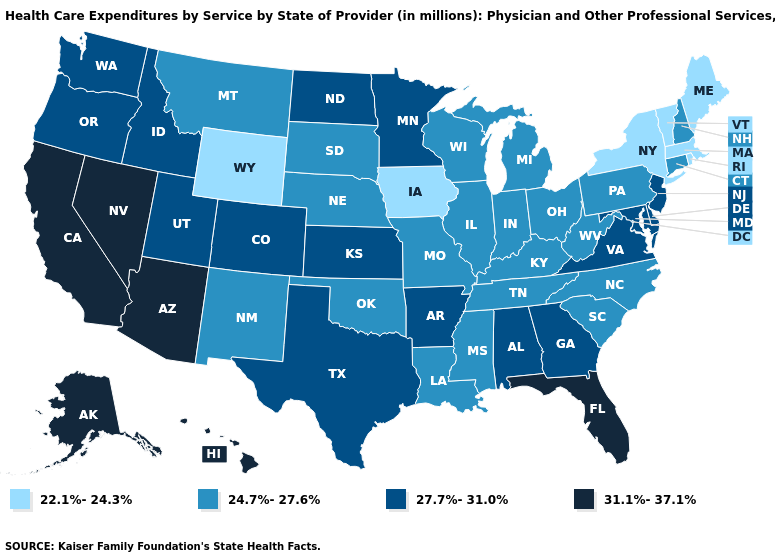Does Alaska have the highest value in the West?
Keep it brief. Yes. Which states have the highest value in the USA?
Concise answer only. Alaska, Arizona, California, Florida, Hawaii, Nevada. Does Arkansas have the highest value in the South?
Short answer required. No. Which states have the highest value in the USA?
Keep it brief. Alaska, Arizona, California, Florida, Hawaii, Nevada. What is the value of Ohio?
Quick response, please. 24.7%-27.6%. How many symbols are there in the legend?
Be succinct. 4. Name the states that have a value in the range 27.7%-31.0%?
Keep it brief. Alabama, Arkansas, Colorado, Delaware, Georgia, Idaho, Kansas, Maryland, Minnesota, New Jersey, North Dakota, Oregon, Texas, Utah, Virginia, Washington. Name the states that have a value in the range 27.7%-31.0%?
Give a very brief answer. Alabama, Arkansas, Colorado, Delaware, Georgia, Idaho, Kansas, Maryland, Minnesota, New Jersey, North Dakota, Oregon, Texas, Utah, Virginia, Washington. What is the value of North Dakota?
Be succinct. 27.7%-31.0%. Does Illinois have the highest value in the MidWest?
Give a very brief answer. No. What is the highest value in states that border Colorado?
Answer briefly. 31.1%-37.1%. Does the map have missing data?
Concise answer only. No. Is the legend a continuous bar?
Answer briefly. No. What is the value of Oklahoma?
Write a very short answer. 24.7%-27.6%. Name the states that have a value in the range 24.7%-27.6%?
Answer briefly. Connecticut, Illinois, Indiana, Kentucky, Louisiana, Michigan, Mississippi, Missouri, Montana, Nebraska, New Hampshire, New Mexico, North Carolina, Ohio, Oklahoma, Pennsylvania, South Carolina, South Dakota, Tennessee, West Virginia, Wisconsin. 